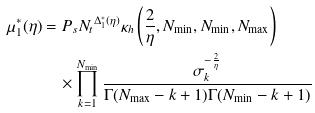Convert formula to latex. <formula><loc_0><loc_0><loc_500><loc_500>\mu ^ { * } _ { 1 } ( \eta ) & = P _ { s } { N _ { t } } ^ { \Delta _ { 1 } ^ { * } ( \eta ) } \kappa _ { h } \left ( \frac { 2 } { \eta } , N _ { \min } , N _ { \min } , N _ { \max } \right ) \\ & \quad \times \prod _ { k = 1 } ^ { N _ { \min } } \frac { \sigma _ { k } ^ { - \frac { 2 } { \eta } } } { \Gamma ( N _ { \max } - k + 1 ) \Gamma ( N _ { \min } - k + 1 ) }</formula> 